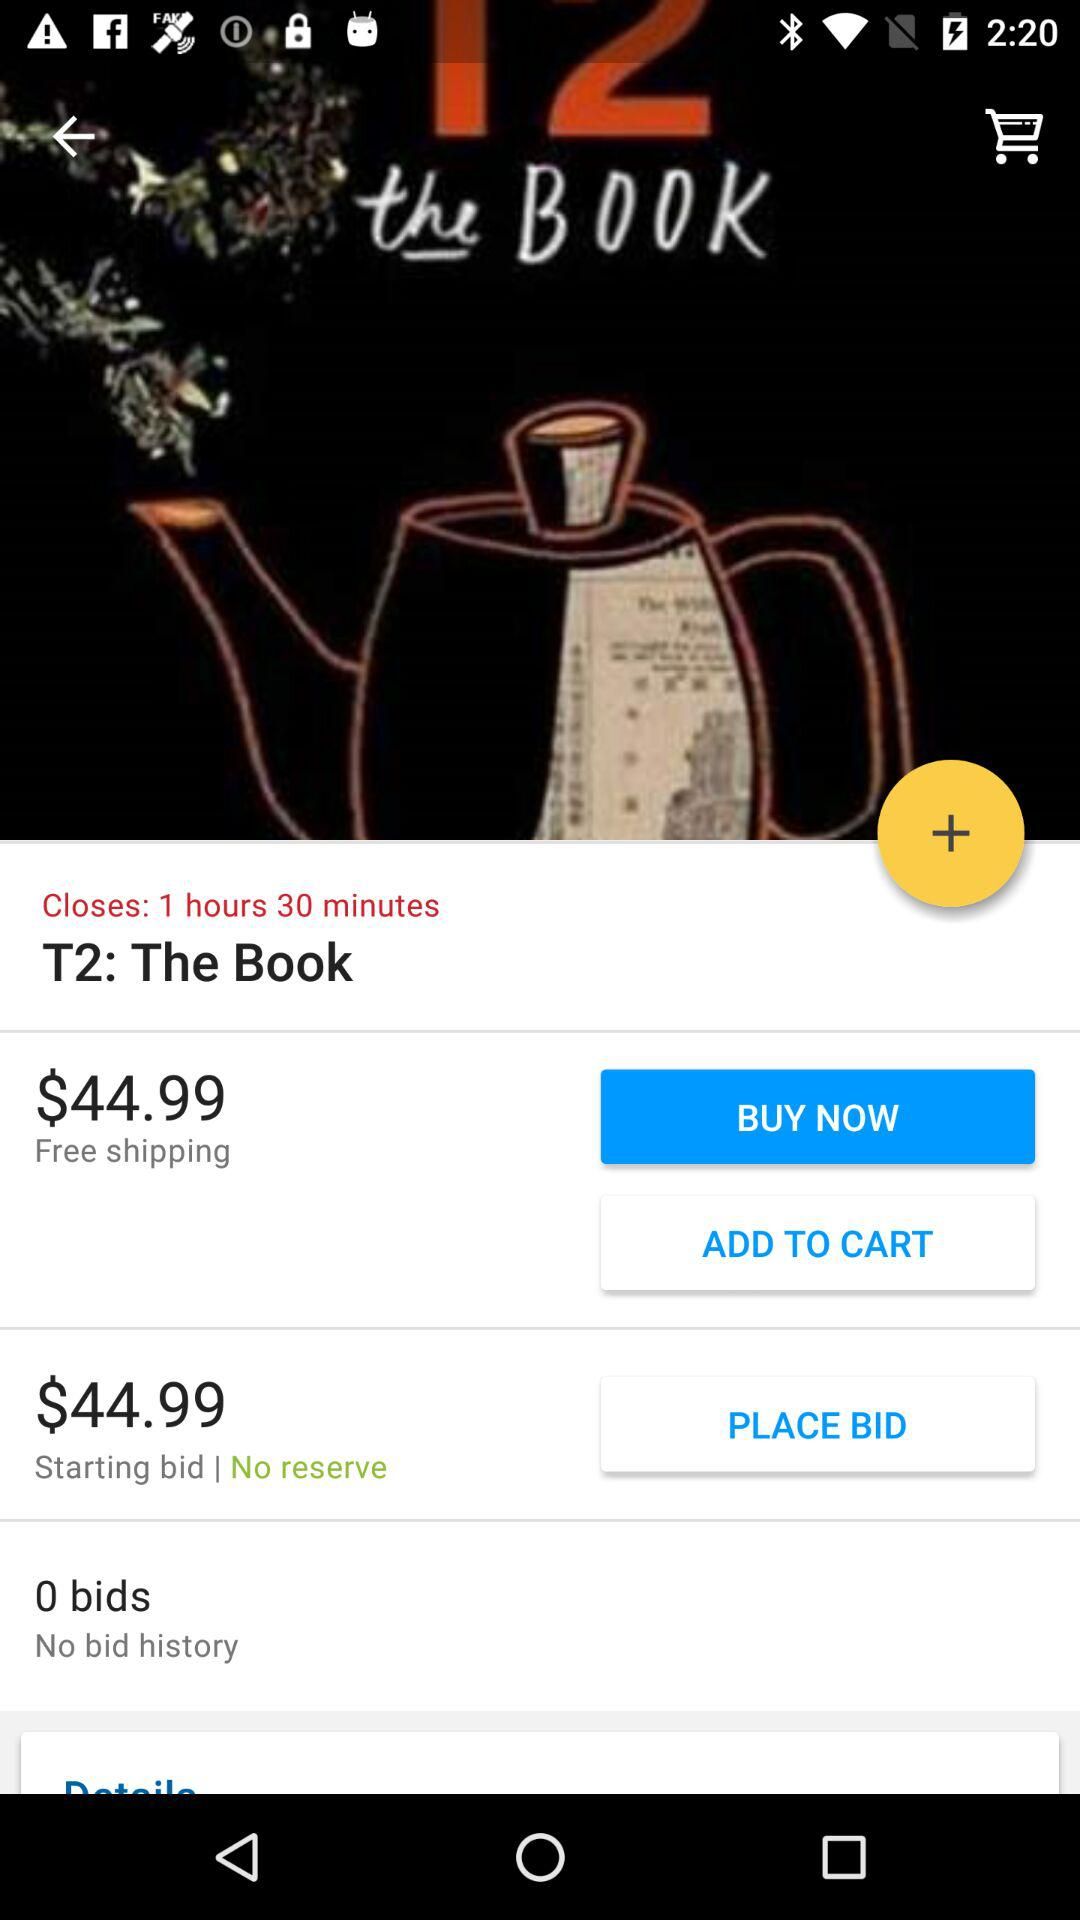What is the price of the book? The price of the book is $44.99. 